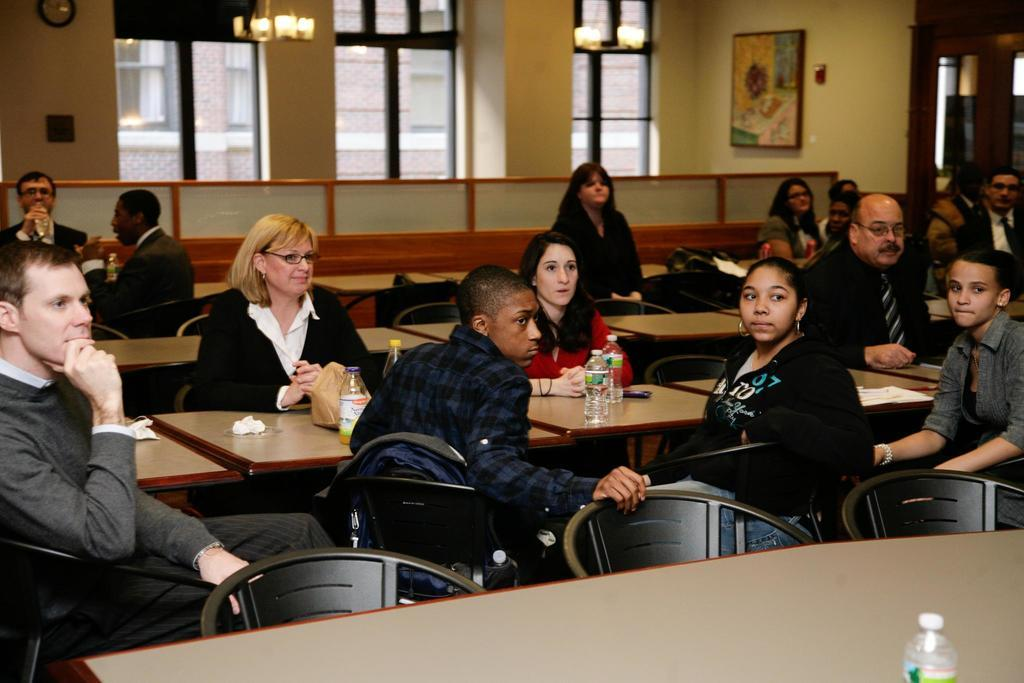How many people are in the image? There are several people in the image. What are the people doing in the image? The people are sitting on a table. What direction are the people looking in the image? The people are looking at one corner of the image. What type of hook can be seen hanging from the ceiling in the image? There is no hook visible in the image; it only shows people sitting on a table and looking at one corner. 